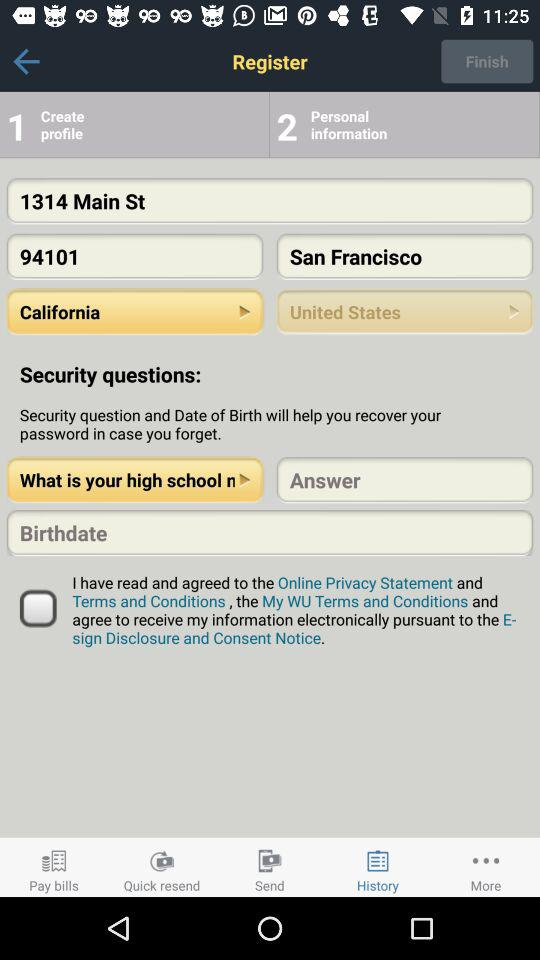Which security question helps to recover password?
When the provided information is insufficient, respond with <no answer>. <no answer> 